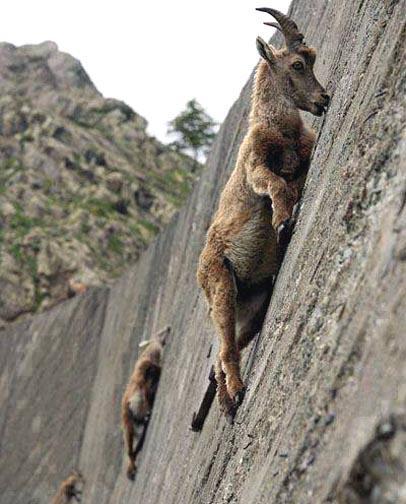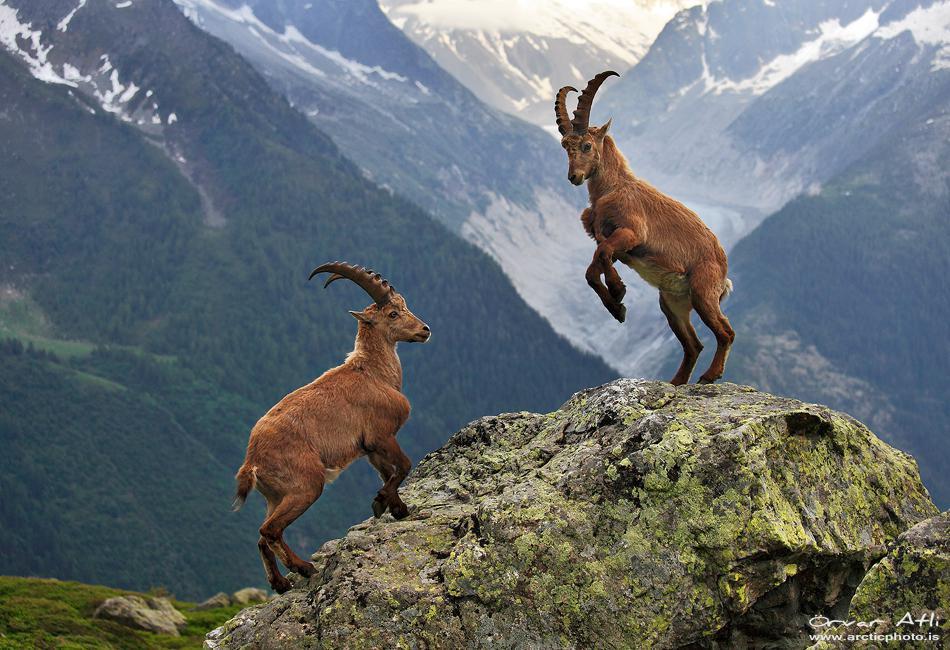The first image is the image on the left, the second image is the image on the right. For the images shown, is this caption "Each individual image has exactly one animal in it." true? Answer yes or no. No. 